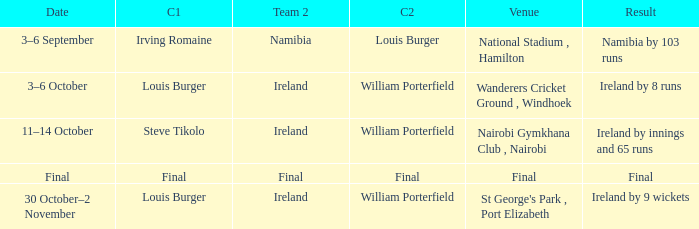Which Captain 2 has a Result of final? Final. 